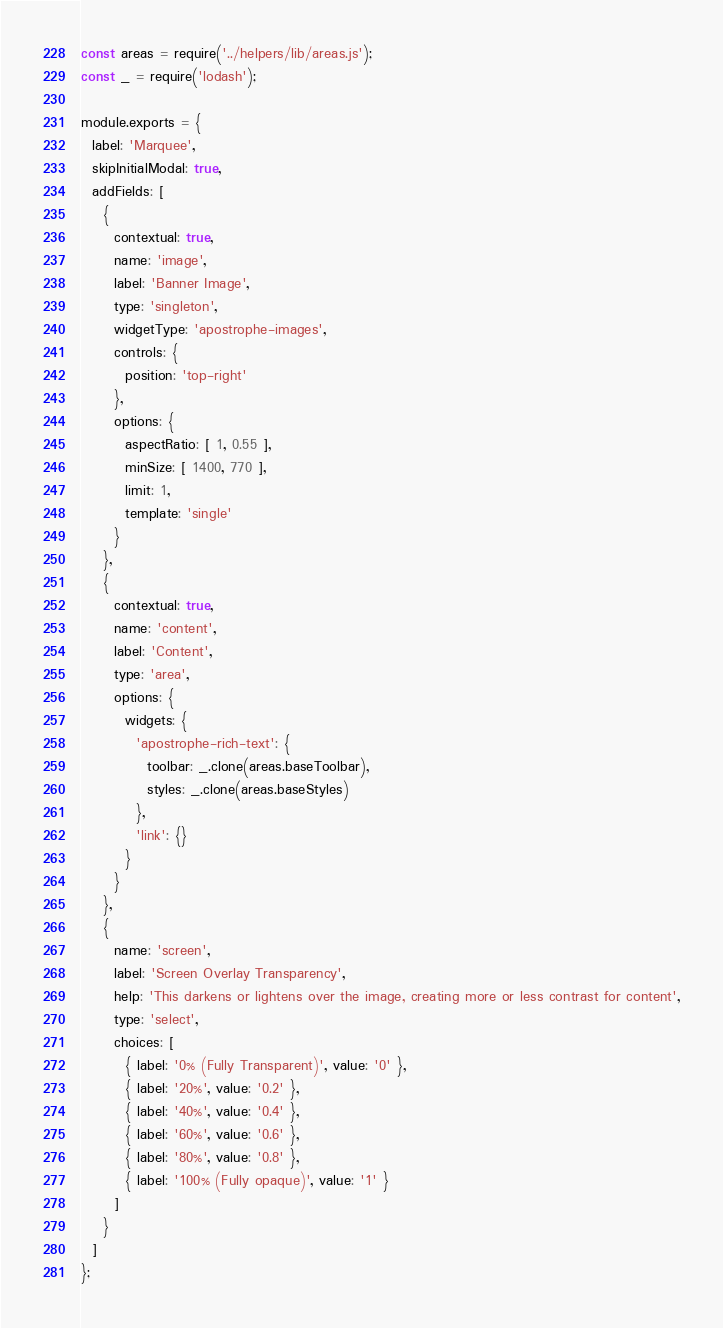Convert code to text. <code><loc_0><loc_0><loc_500><loc_500><_JavaScript_>const areas = require('../helpers/lib/areas.js');
const _ = require('lodash');

module.exports = {
  label: 'Marquee',
  skipInitialModal: true,
  addFields: [
    {
      contextual: true,
      name: 'image',
      label: 'Banner Image',
      type: 'singleton',
      widgetType: 'apostrophe-images',
      controls: {
        position: 'top-right'
      },
      options: {
        aspectRatio: [ 1, 0.55 ],
        minSize: [ 1400, 770 ],
        limit: 1,
        template: 'single'
      }
    },
    {
      contextual: true,
      name: 'content',
      label: 'Content',
      type: 'area',
      options: {
        widgets: {
          'apostrophe-rich-text': {
            toolbar: _.clone(areas.baseToolbar),
            styles: _.clone(areas.baseStyles)
          },
          'link': {}
        }
      }
    },
    {
      name: 'screen',
      label: 'Screen Overlay Transparency',
      help: 'This darkens or lightens over the image, creating more or less contrast for content',
      type: 'select',
      choices: [
        { label: '0% (Fully Transparent)', value: '0' },
        { label: '20%', value: '0.2' },
        { label: '40%', value: '0.4' },
        { label: '60%', value: '0.6' },
        { label: '80%', value: '0.8' },
        { label: '100% (Fully opaque)', value: '1' }
      ]
    }
  ]
};
</code> 